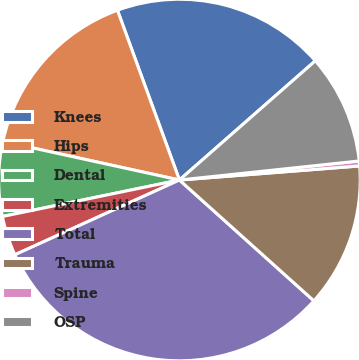Convert chart. <chart><loc_0><loc_0><loc_500><loc_500><pie_chart><fcel>Knees<fcel>Hips<fcel>Dental<fcel>Extremities<fcel>Total<fcel>Trauma<fcel>Spine<fcel>OSP<nl><fcel>19.11%<fcel>16.0%<fcel>6.66%<fcel>3.55%<fcel>31.56%<fcel>12.89%<fcel>0.44%<fcel>9.78%<nl></chart> 